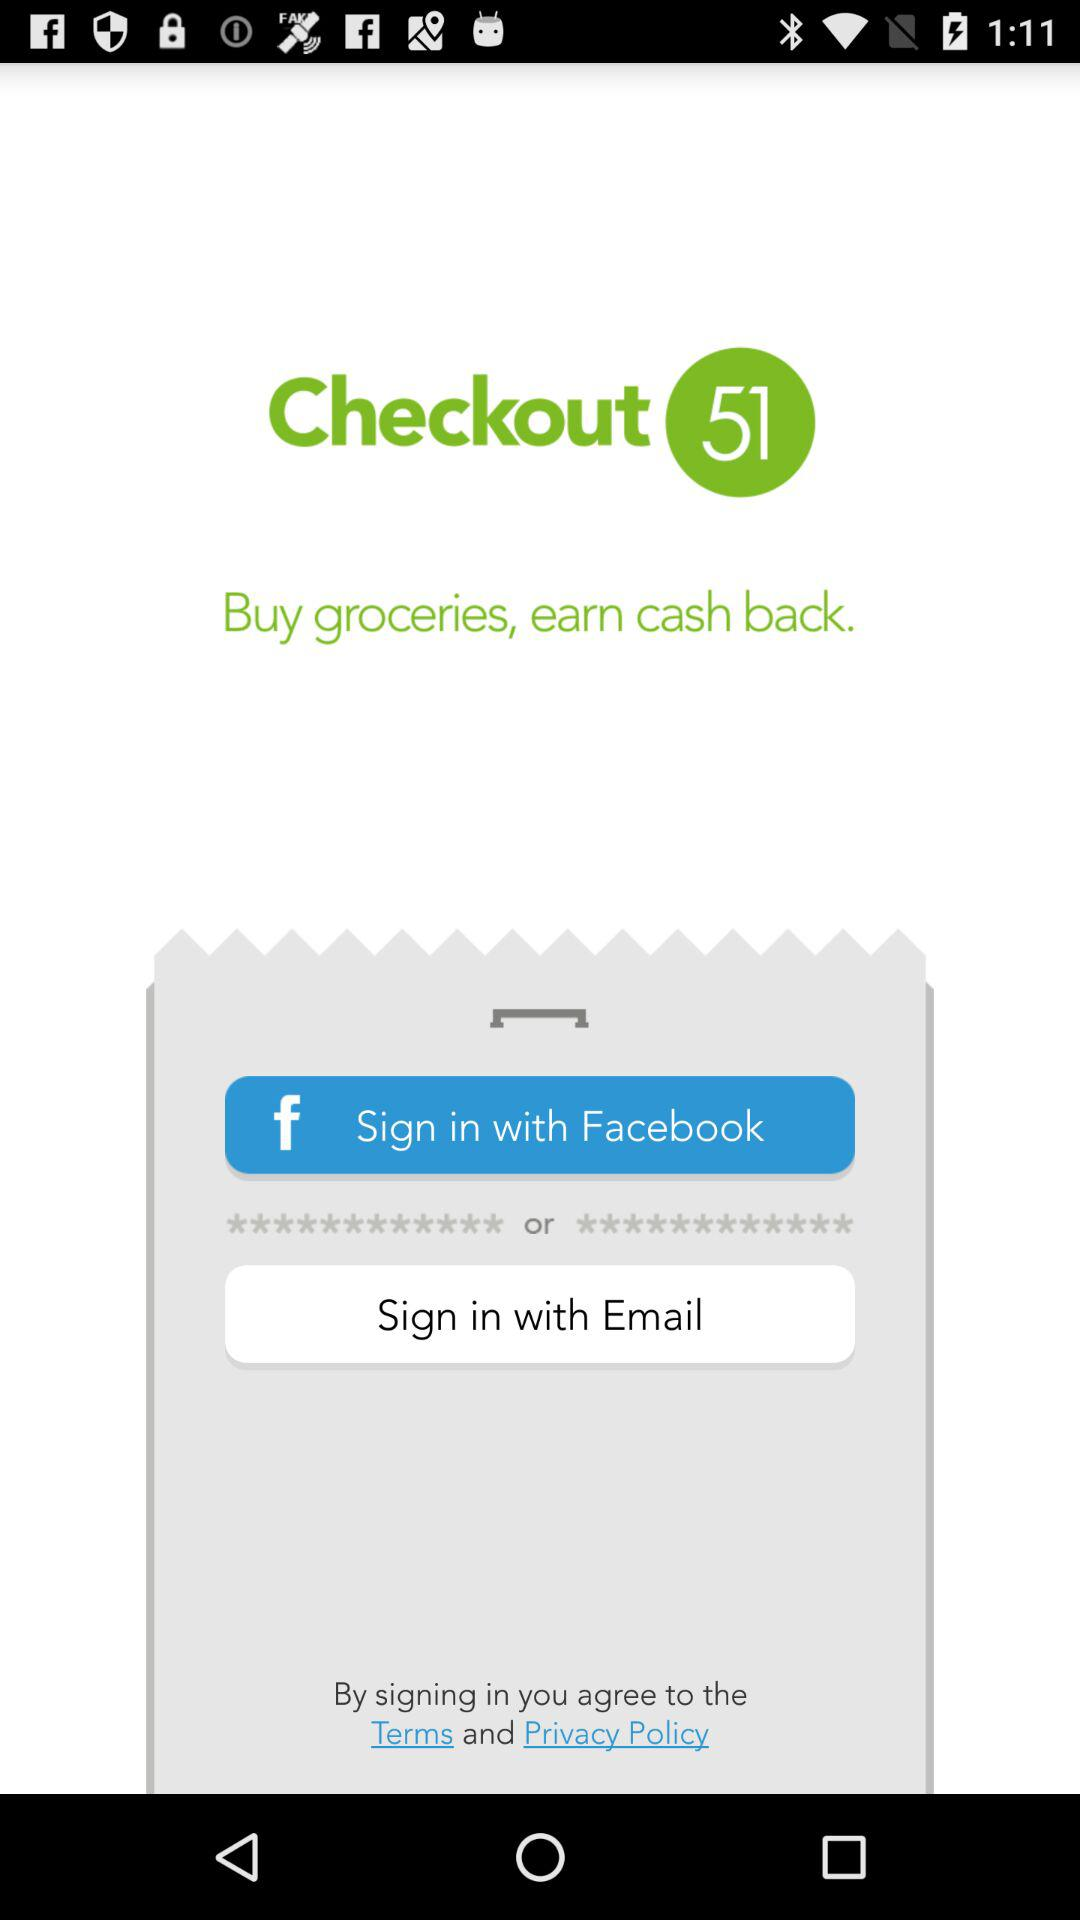What application can we use to sign in? The applications you can use to sign in are "Facebook" and "Email". 